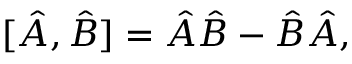<formula> <loc_0><loc_0><loc_500><loc_500>[ { \hat { A } } , { \hat { B } } ] = { \hat { A } } { \hat { B } } - { \hat { B } } { \hat { A } } ,</formula> 